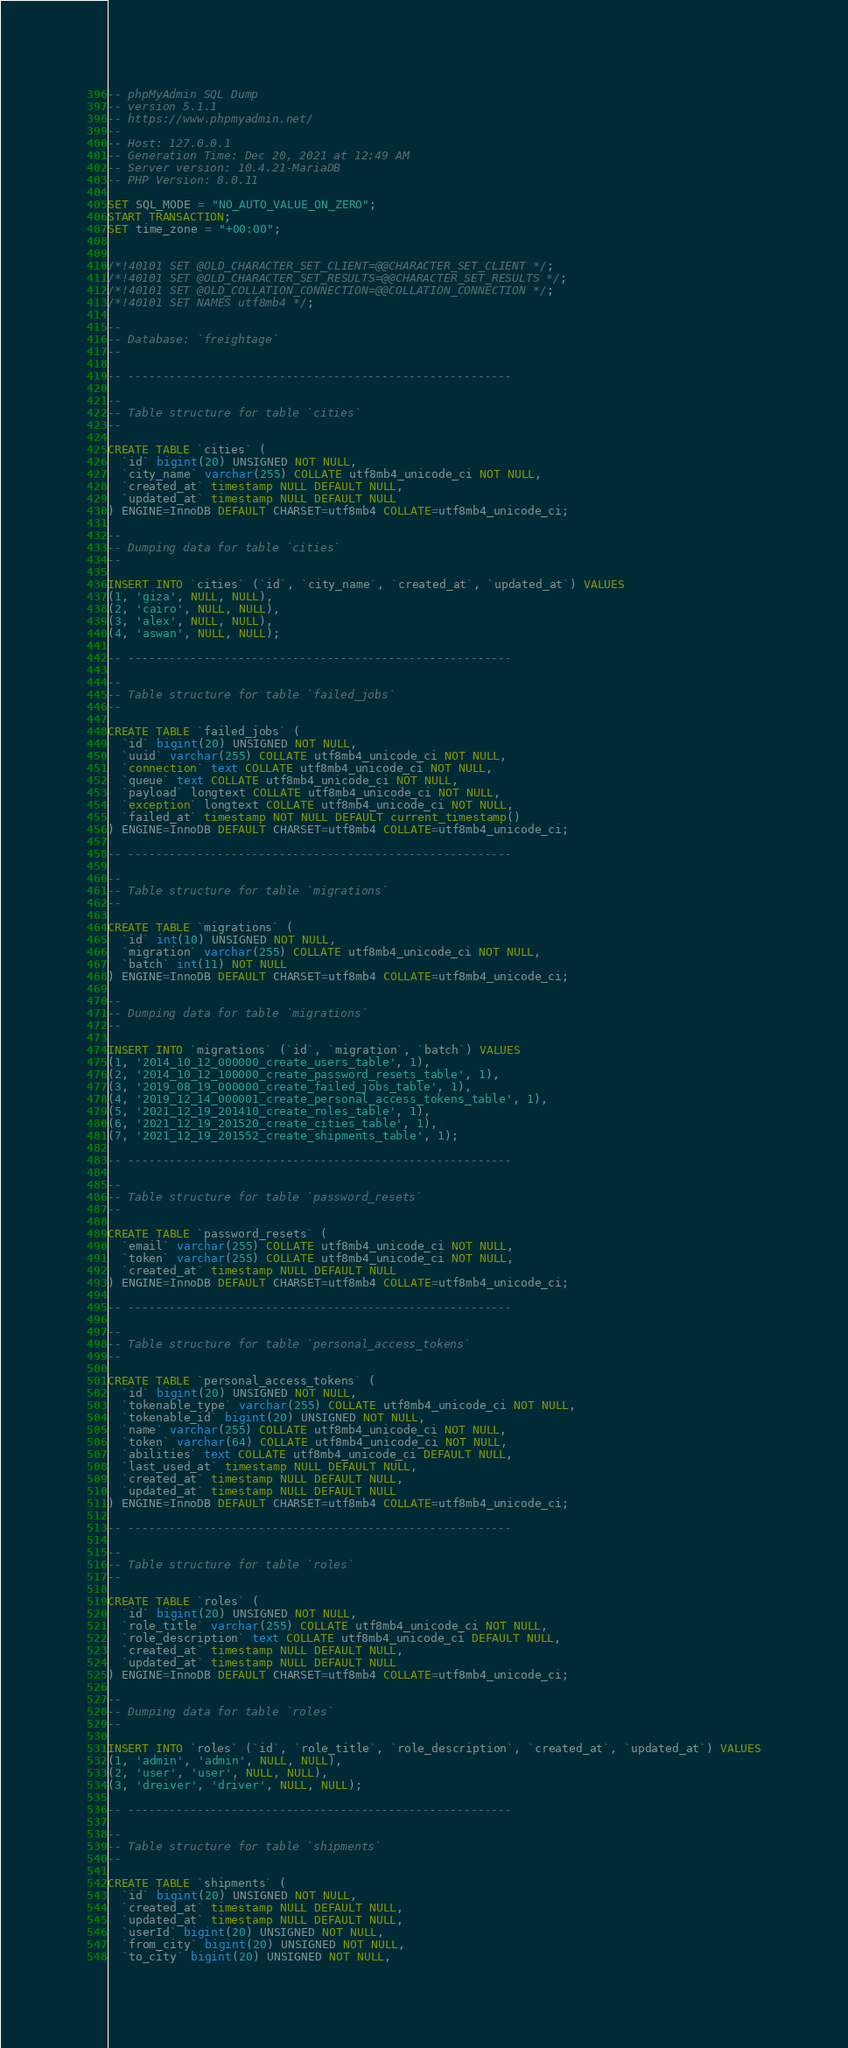Convert code to text. <code><loc_0><loc_0><loc_500><loc_500><_SQL_>-- phpMyAdmin SQL Dump
-- version 5.1.1
-- https://www.phpmyadmin.net/
--
-- Host: 127.0.0.1
-- Generation Time: Dec 20, 2021 at 12:49 AM
-- Server version: 10.4.21-MariaDB
-- PHP Version: 8.0.11

SET SQL_MODE = "NO_AUTO_VALUE_ON_ZERO";
START TRANSACTION;
SET time_zone = "+00:00";


/*!40101 SET @OLD_CHARACTER_SET_CLIENT=@@CHARACTER_SET_CLIENT */;
/*!40101 SET @OLD_CHARACTER_SET_RESULTS=@@CHARACTER_SET_RESULTS */;
/*!40101 SET @OLD_COLLATION_CONNECTION=@@COLLATION_CONNECTION */;
/*!40101 SET NAMES utf8mb4 */;

--
-- Database: `freightage`
--

-- --------------------------------------------------------

--
-- Table structure for table `cities`
--

CREATE TABLE `cities` (
  `id` bigint(20) UNSIGNED NOT NULL,
  `city_name` varchar(255) COLLATE utf8mb4_unicode_ci NOT NULL,
  `created_at` timestamp NULL DEFAULT NULL,
  `updated_at` timestamp NULL DEFAULT NULL
) ENGINE=InnoDB DEFAULT CHARSET=utf8mb4 COLLATE=utf8mb4_unicode_ci;

--
-- Dumping data for table `cities`
--

INSERT INTO `cities` (`id`, `city_name`, `created_at`, `updated_at`) VALUES
(1, 'giza', NULL, NULL),
(2, 'cairo', NULL, NULL),
(3, 'alex', NULL, NULL),
(4, 'aswan', NULL, NULL);

-- --------------------------------------------------------

--
-- Table structure for table `failed_jobs`
--

CREATE TABLE `failed_jobs` (
  `id` bigint(20) UNSIGNED NOT NULL,
  `uuid` varchar(255) COLLATE utf8mb4_unicode_ci NOT NULL,
  `connection` text COLLATE utf8mb4_unicode_ci NOT NULL,
  `queue` text COLLATE utf8mb4_unicode_ci NOT NULL,
  `payload` longtext COLLATE utf8mb4_unicode_ci NOT NULL,
  `exception` longtext COLLATE utf8mb4_unicode_ci NOT NULL,
  `failed_at` timestamp NOT NULL DEFAULT current_timestamp()
) ENGINE=InnoDB DEFAULT CHARSET=utf8mb4 COLLATE=utf8mb4_unicode_ci;

-- --------------------------------------------------------

--
-- Table structure for table `migrations`
--

CREATE TABLE `migrations` (
  `id` int(10) UNSIGNED NOT NULL,
  `migration` varchar(255) COLLATE utf8mb4_unicode_ci NOT NULL,
  `batch` int(11) NOT NULL
) ENGINE=InnoDB DEFAULT CHARSET=utf8mb4 COLLATE=utf8mb4_unicode_ci;

--
-- Dumping data for table `migrations`
--

INSERT INTO `migrations` (`id`, `migration`, `batch`) VALUES
(1, '2014_10_12_000000_create_users_table', 1),
(2, '2014_10_12_100000_create_password_resets_table', 1),
(3, '2019_08_19_000000_create_failed_jobs_table', 1),
(4, '2019_12_14_000001_create_personal_access_tokens_table', 1),
(5, '2021_12_19_201410_create_roles_table', 1),
(6, '2021_12_19_201520_create_cities_table', 1),
(7, '2021_12_19_201552_create_shipments_table', 1);

-- --------------------------------------------------------

--
-- Table structure for table `password_resets`
--

CREATE TABLE `password_resets` (
  `email` varchar(255) COLLATE utf8mb4_unicode_ci NOT NULL,
  `token` varchar(255) COLLATE utf8mb4_unicode_ci NOT NULL,
  `created_at` timestamp NULL DEFAULT NULL
) ENGINE=InnoDB DEFAULT CHARSET=utf8mb4 COLLATE=utf8mb4_unicode_ci;

-- --------------------------------------------------------

--
-- Table structure for table `personal_access_tokens`
--

CREATE TABLE `personal_access_tokens` (
  `id` bigint(20) UNSIGNED NOT NULL,
  `tokenable_type` varchar(255) COLLATE utf8mb4_unicode_ci NOT NULL,
  `tokenable_id` bigint(20) UNSIGNED NOT NULL,
  `name` varchar(255) COLLATE utf8mb4_unicode_ci NOT NULL,
  `token` varchar(64) COLLATE utf8mb4_unicode_ci NOT NULL,
  `abilities` text COLLATE utf8mb4_unicode_ci DEFAULT NULL,
  `last_used_at` timestamp NULL DEFAULT NULL,
  `created_at` timestamp NULL DEFAULT NULL,
  `updated_at` timestamp NULL DEFAULT NULL
) ENGINE=InnoDB DEFAULT CHARSET=utf8mb4 COLLATE=utf8mb4_unicode_ci;

-- --------------------------------------------------------

--
-- Table structure for table `roles`
--

CREATE TABLE `roles` (
  `id` bigint(20) UNSIGNED NOT NULL,
  `role_title` varchar(255) COLLATE utf8mb4_unicode_ci NOT NULL,
  `role_description` text COLLATE utf8mb4_unicode_ci DEFAULT NULL,
  `created_at` timestamp NULL DEFAULT NULL,
  `updated_at` timestamp NULL DEFAULT NULL
) ENGINE=InnoDB DEFAULT CHARSET=utf8mb4 COLLATE=utf8mb4_unicode_ci;

--
-- Dumping data for table `roles`
--

INSERT INTO `roles` (`id`, `role_title`, `role_description`, `created_at`, `updated_at`) VALUES
(1, 'admin', 'admin', NULL, NULL),
(2, 'user', 'user', NULL, NULL),
(3, 'dreiver', 'driver', NULL, NULL);

-- --------------------------------------------------------

--
-- Table structure for table `shipments`
--

CREATE TABLE `shipments` (
  `id` bigint(20) UNSIGNED NOT NULL,
  `created_at` timestamp NULL DEFAULT NULL,
  `updated_at` timestamp NULL DEFAULT NULL,
  `userId` bigint(20) UNSIGNED NOT NULL,
  `from_city` bigint(20) UNSIGNED NOT NULL,
  `to_city` bigint(20) UNSIGNED NOT NULL,</code> 